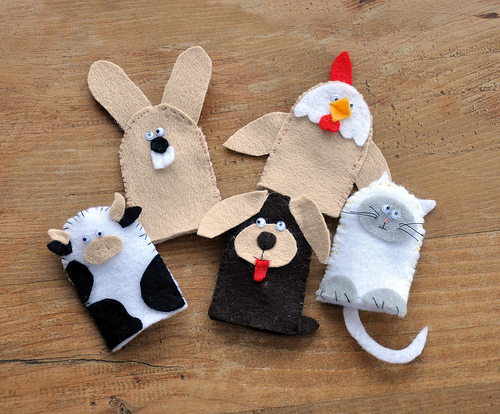<image>
Can you confirm if the cow is on the cat? No. The cow is not positioned on the cat. They may be near each other, but the cow is not supported by or resting on top of the cat. 